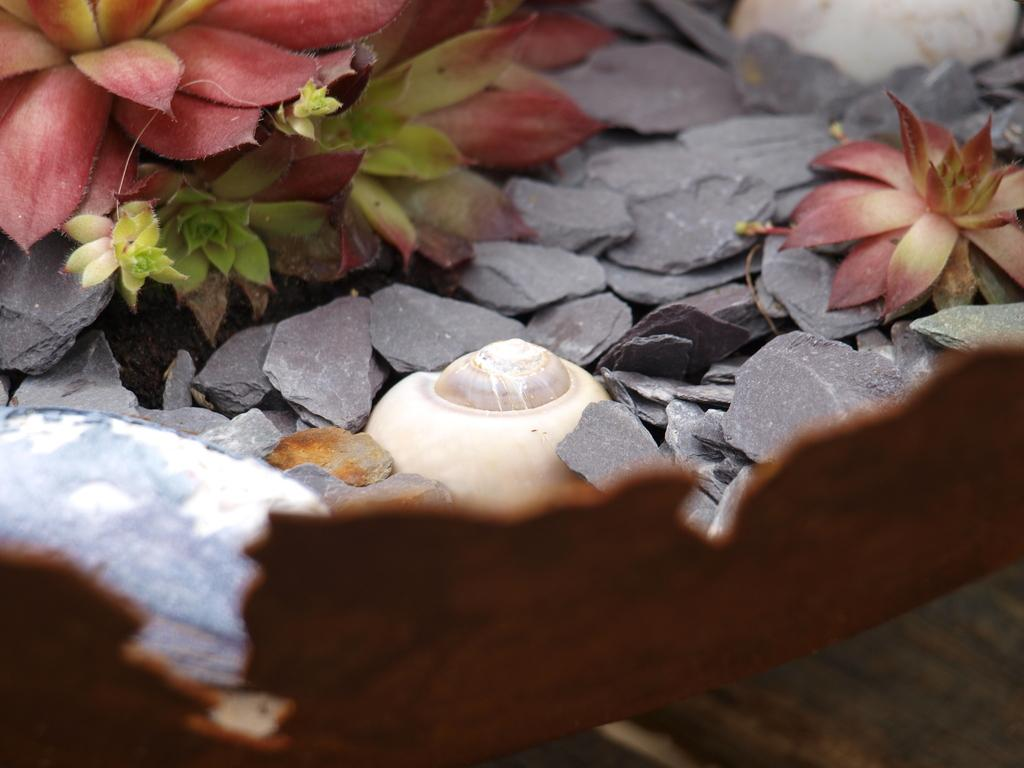What type of object can be seen in the image? There is a shell in the image. What else can be found in the image? There are stones and plants in the image. What type of flesh can be seen in the image? There is no flesh present in the image; it features a shell, stones, and plants. What type of stocking is visible in the image? There is no stocking present in the image. 